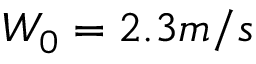<formula> <loc_0><loc_0><loc_500><loc_500>W _ { 0 } = 2 . 3 m / s</formula> 